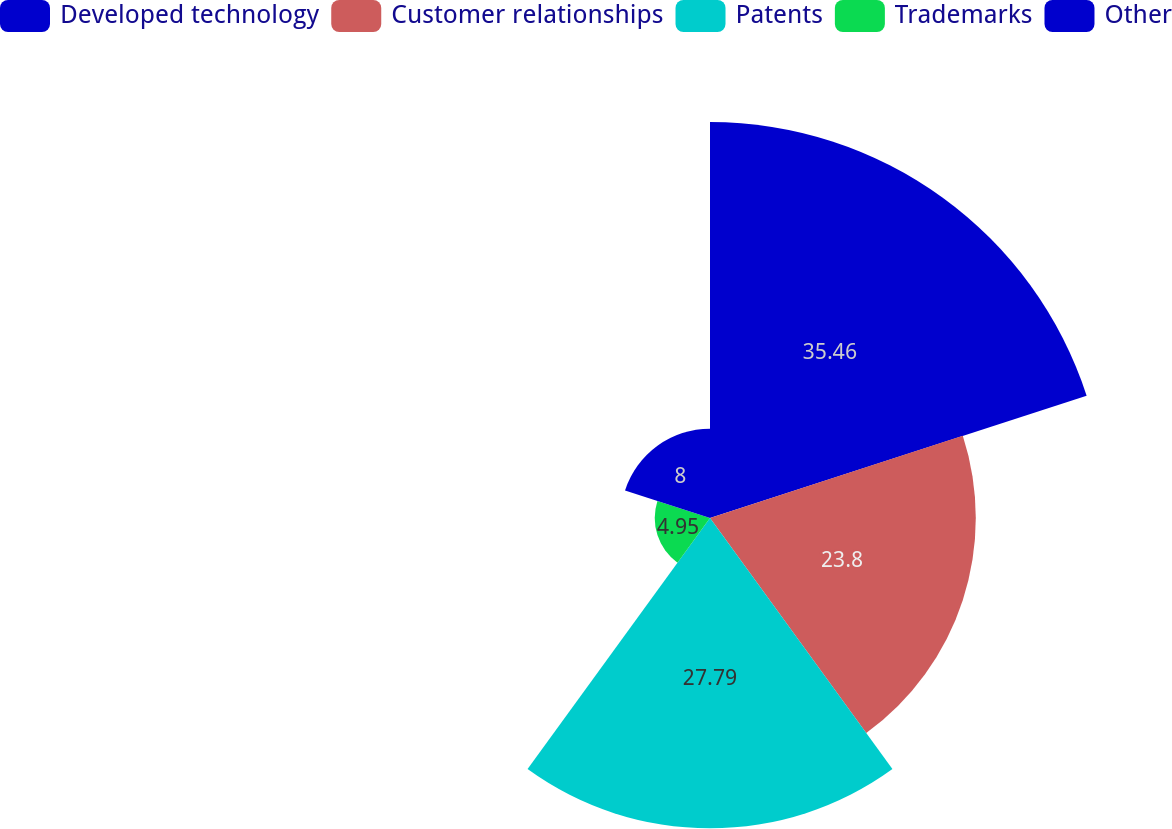Convert chart. <chart><loc_0><loc_0><loc_500><loc_500><pie_chart><fcel>Developed technology<fcel>Customer relationships<fcel>Patents<fcel>Trademarks<fcel>Other<nl><fcel>35.46%<fcel>23.8%<fcel>27.79%<fcel>4.95%<fcel>8.0%<nl></chart> 